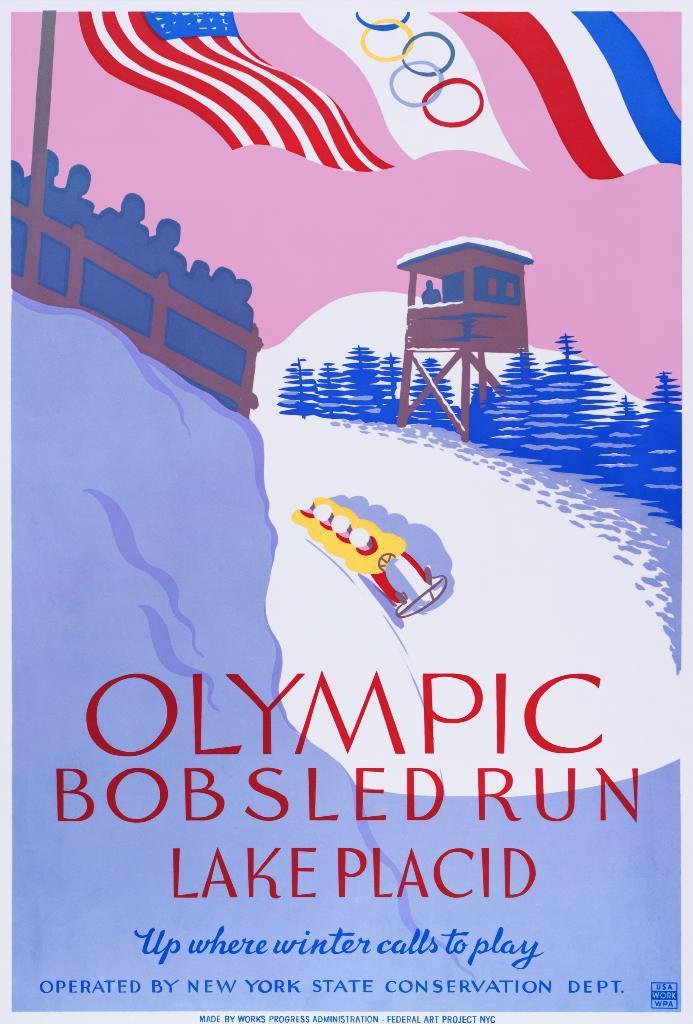Describe this image in one or two sentences. Here we can see a poster. There are few persons, flags, plants, and a pole. 